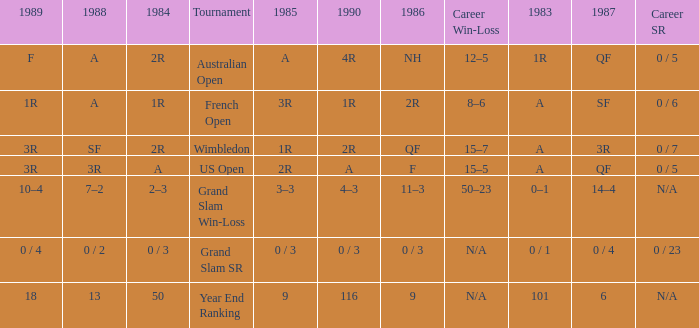With a 1986 of NH and a career SR of 0 / 5 what is the results in 1985? A. 